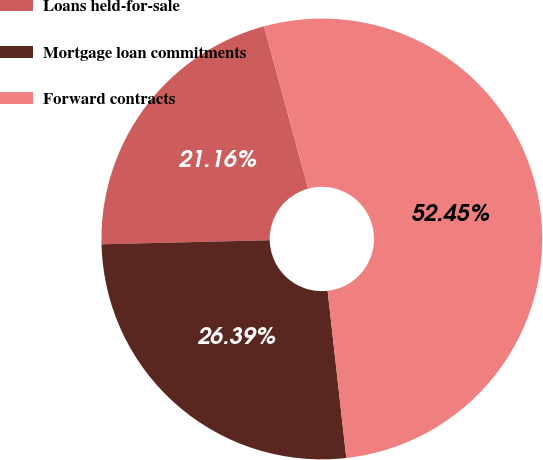Convert chart. <chart><loc_0><loc_0><loc_500><loc_500><pie_chart><fcel>Loans held-for-sale<fcel>Mortgage loan commitments<fcel>Forward contracts<nl><fcel>21.16%<fcel>26.39%<fcel>52.46%<nl></chart> 